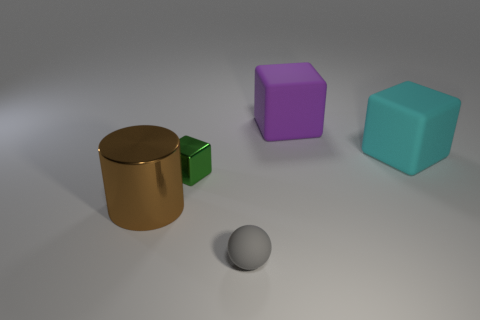There is a small green object that is the same shape as the cyan thing; what material is it?
Ensure brevity in your answer.  Metal. There is a thing that is right of the large brown cylinder and in front of the tiny green thing; what is its material?
Give a very brief answer. Rubber. Is the tiny green thing made of the same material as the big purple cube?
Your response must be concise. No. There is a matte thing that is both to the left of the cyan rubber thing and behind the big brown thing; how big is it?
Keep it short and to the point. Large. What shape is the purple object?
Offer a very short reply. Cube. How many objects are large blue matte blocks or blocks that are to the right of the large purple rubber thing?
Keep it short and to the point. 1. The thing that is in front of the tiny green metal cube and on the right side of the small green object is what color?
Provide a short and direct response. Gray. What is the material of the purple cube behind the small green object?
Your answer should be very brief. Rubber. What size is the brown thing?
Keep it short and to the point. Large. What number of gray objects are either spheres or cylinders?
Provide a short and direct response. 1. 